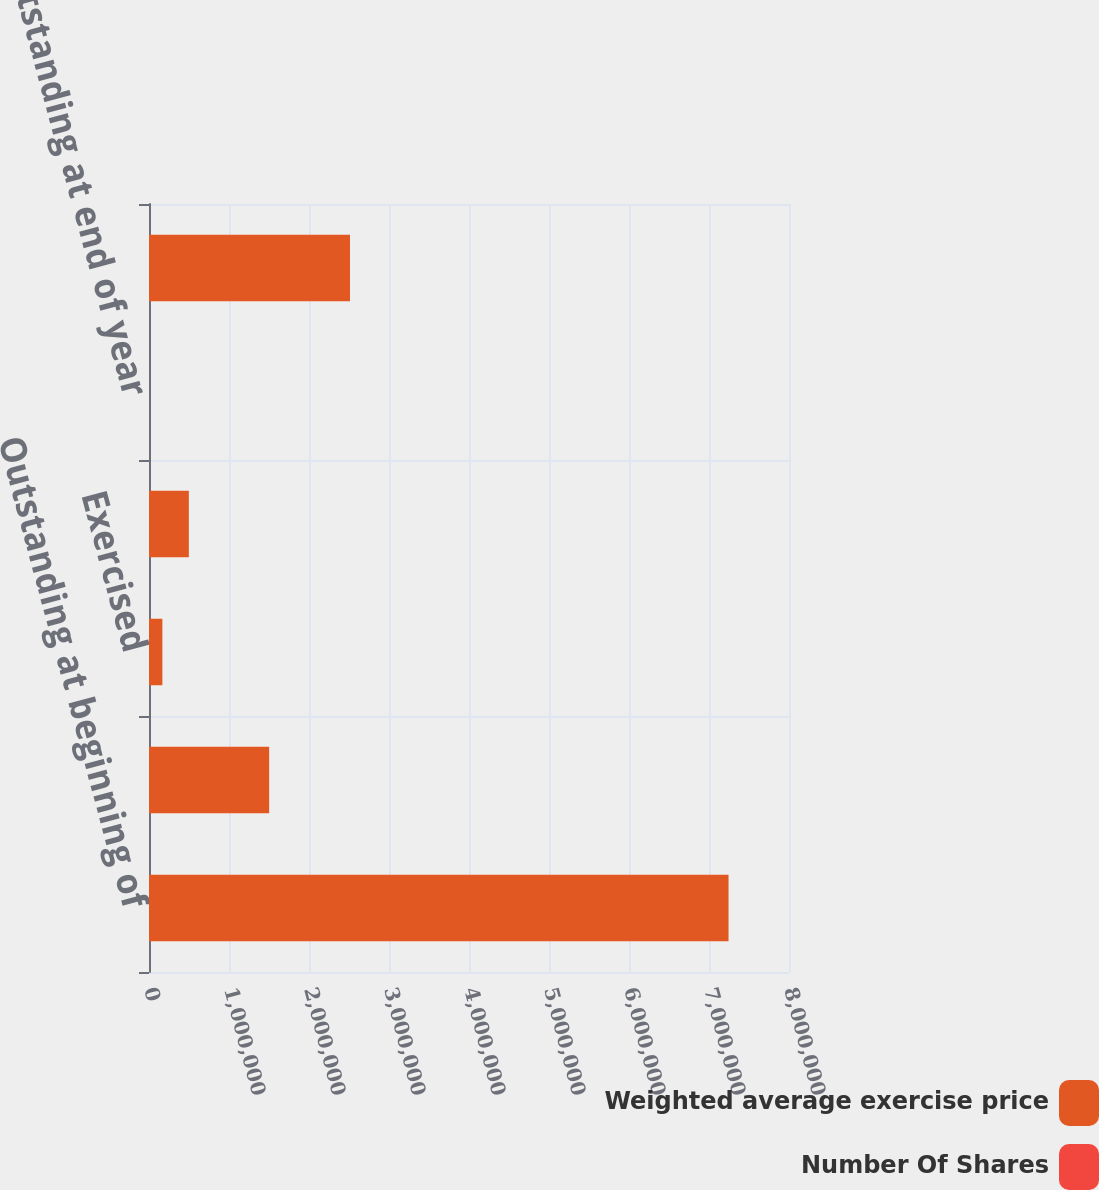<chart> <loc_0><loc_0><loc_500><loc_500><stacked_bar_chart><ecel><fcel>Outstanding at beginning of<fcel>Granted<fcel>Exercised<fcel>Forfeited<fcel>Outstanding at end of year<fcel>Options exercisable at<nl><fcel>Weighted average exercise price<fcel>7.24422e+06<fcel>1.50173e+06<fcel>167092<fcel>497997<fcel>43.5<fcel>2.51236e+06<nl><fcel>Number Of Shares<fcel>28.79<fcel>43.5<fcel>19.4<fcel>36.17<fcel>31.28<fcel>24.94<nl></chart> 